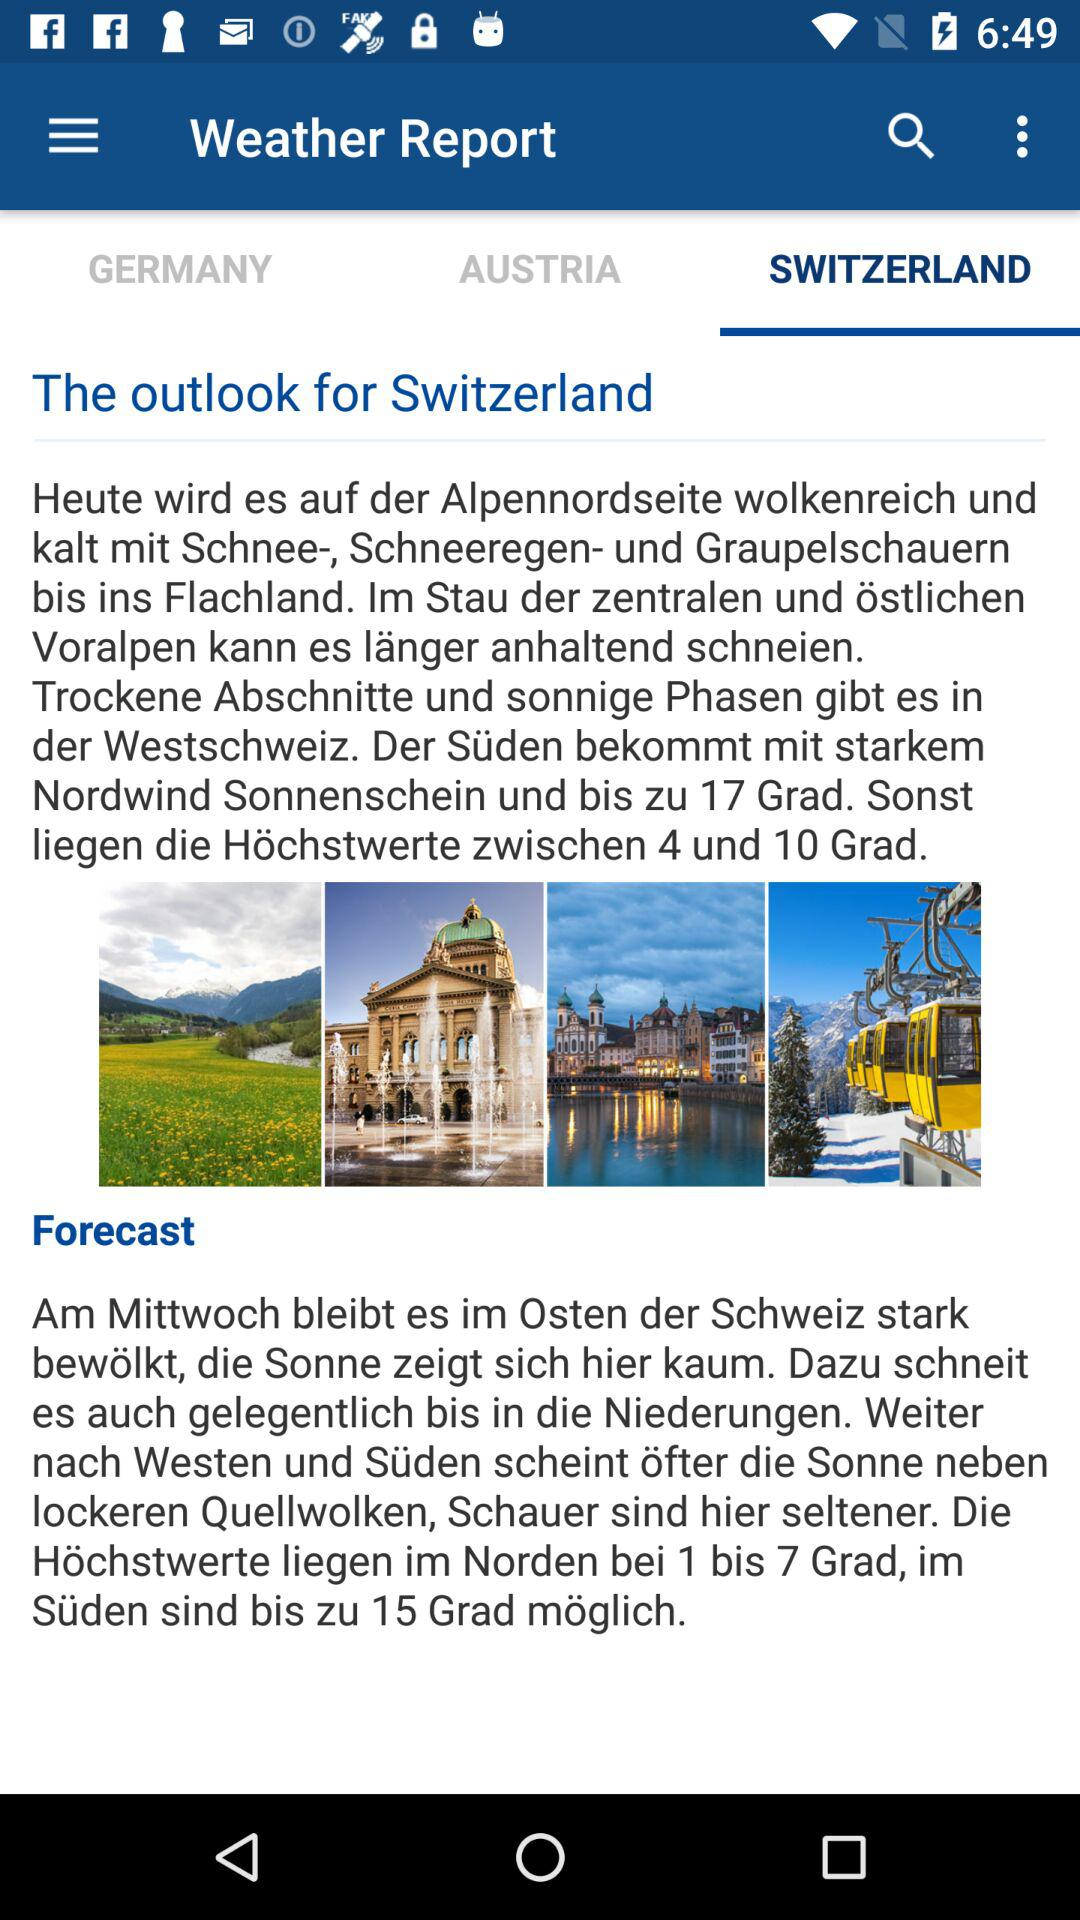Which tab is selected? The selected tab is "SWITZERLAND". 